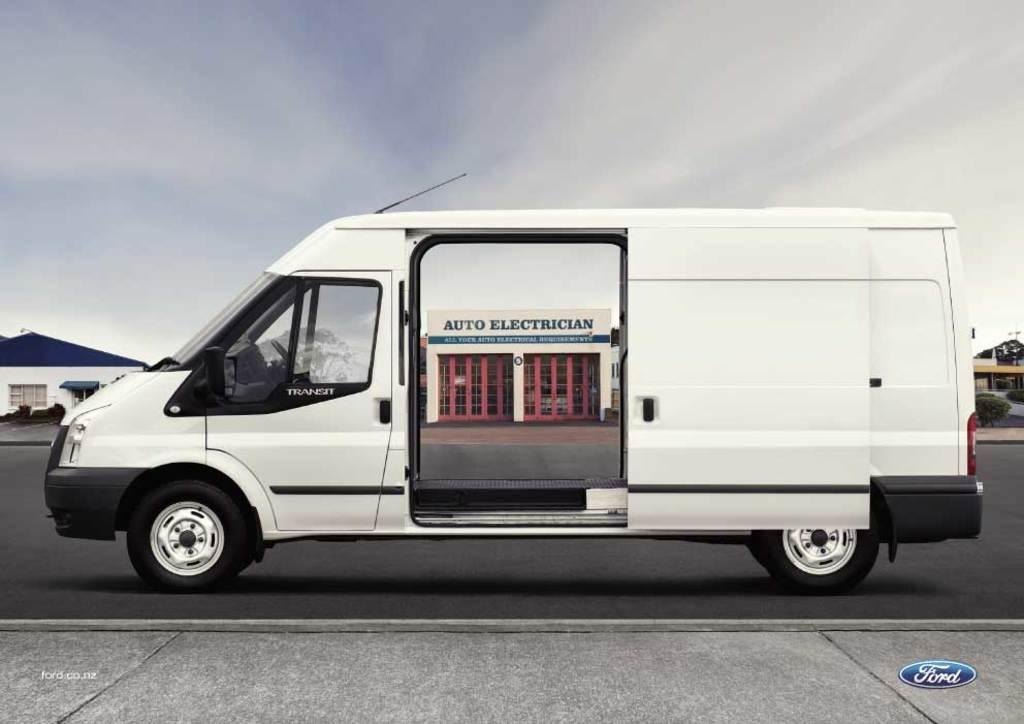<image>
Create a compact narrative representing the image presented. An auto electrician van with the store front on the outside of the van. 